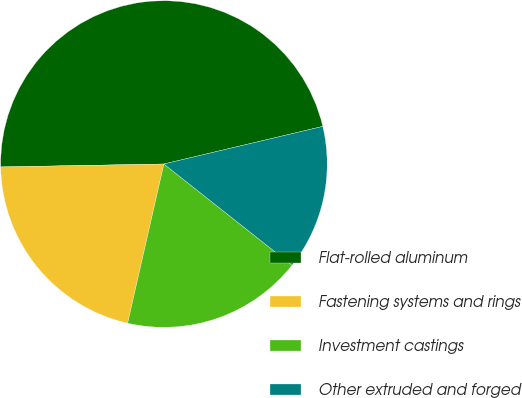Convert chart. <chart><loc_0><loc_0><loc_500><loc_500><pie_chart><fcel>Flat-rolled aluminum<fcel>Fastening systems and rings<fcel>Investment castings<fcel>Other extruded and forged<nl><fcel>46.59%<fcel>21.15%<fcel>17.92%<fcel>14.34%<nl></chart> 